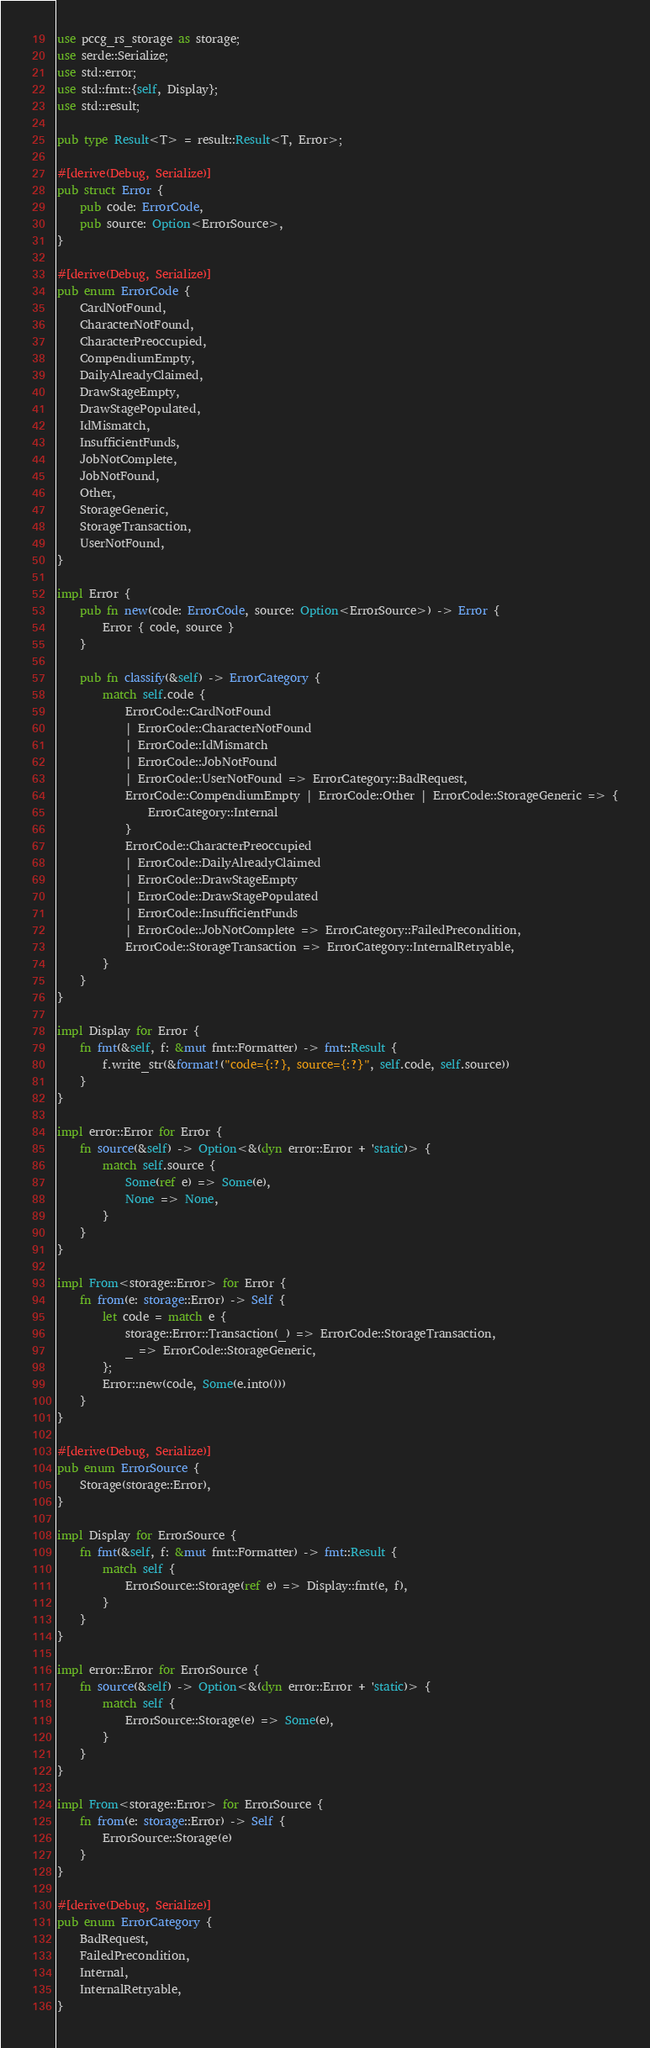<code> <loc_0><loc_0><loc_500><loc_500><_Rust_>use pccg_rs_storage as storage;
use serde::Serialize;
use std::error;
use std::fmt::{self, Display};
use std::result;

pub type Result<T> = result::Result<T, Error>;

#[derive(Debug, Serialize)]
pub struct Error {
    pub code: ErrorCode,
    pub source: Option<ErrorSource>,
}

#[derive(Debug, Serialize)]
pub enum ErrorCode {
    CardNotFound,
    CharacterNotFound,
    CharacterPreoccupied,
    CompendiumEmpty,
    DailyAlreadyClaimed,
    DrawStageEmpty,
    DrawStagePopulated,
    IdMismatch,
    InsufficientFunds,
    JobNotComplete,
    JobNotFound,
    Other,
    StorageGeneric,
    StorageTransaction,
    UserNotFound,
}

impl Error {
    pub fn new(code: ErrorCode, source: Option<ErrorSource>) -> Error {
        Error { code, source }
    }

    pub fn classify(&self) -> ErrorCategory {
        match self.code {
            ErrorCode::CardNotFound
            | ErrorCode::CharacterNotFound
            | ErrorCode::IdMismatch
            | ErrorCode::JobNotFound
            | ErrorCode::UserNotFound => ErrorCategory::BadRequest,
            ErrorCode::CompendiumEmpty | ErrorCode::Other | ErrorCode::StorageGeneric => {
                ErrorCategory::Internal
            }
            ErrorCode::CharacterPreoccupied
            | ErrorCode::DailyAlreadyClaimed
            | ErrorCode::DrawStageEmpty
            | ErrorCode::DrawStagePopulated
            | ErrorCode::InsufficientFunds
            | ErrorCode::JobNotComplete => ErrorCategory::FailedPrecondition,
            ErrorCode::StorageTransaction => ErrorCategory::InternalRetryable,
        }
    }
}

impl Display for Error {
    fn fmt(&self, f: &mut fmt::Formatter) -> fmt::Result {
        f.write_str(&format!("code={:?}, source={:?}", self.code, self.source))
    }
}

impl error::Error for Error {
    fn source(&self) -> Option<&(dyn error::Error + 'static)> {
        match self.source {
            Some(ref e) => Some(e),
            None => None,
        }
    }
}

impl From<storage::Error> for Error {
    fn from(e: storage::Error) -> Self {
        let code = match e {
            storage::Error::Transaction(_) => ErrorCode::StorageTransaction,
            _ => ErrorCode::StorageGeneric,
        };
        Error::new(code, Some(e.into()))
    }
}

#[derive(Debug, Serialize)]
pub enum ErrorSource {
    Storage(storage::Error),
}

impl Display for ErrorSource {
    fn fmt(&self, f: &mut fmt::Formatter) -> fmt::Result {
        match self {
            ErrorSource::Storage(ref e) => Display::fmt(e, f),
        }
    }
}

impl error::Error for ErrorSource {
    fn source(&self) -> Option<&(dyn error::Error + 'static)> {
        match self {
            ErrorSource::Storage(e) => Some(e),
        }
    }
}

impl From<storage::Error> for ErrorSource {
    fn from(e: storage::Error) -> Self {
        ErrorSource::Storage(e)
    }
}

#[derive(Debug, Serialize)]
pub enum ErrorCategory {
    BadRequest,
    FailedPrecondition,
    Internal,
    InternalRetryable,
}
</code> 